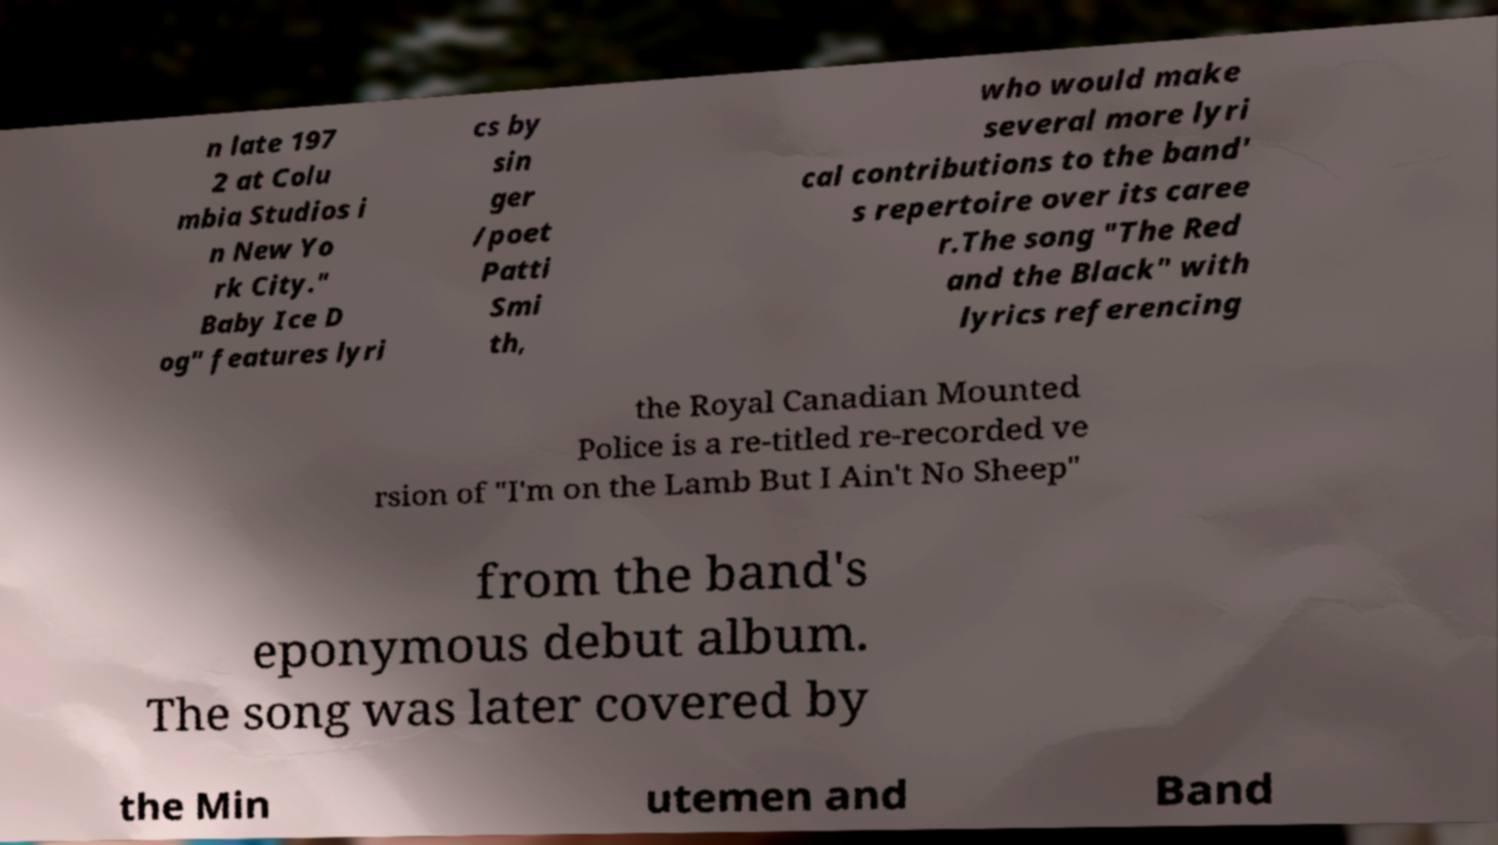Could you assist in decoding the text presented in this image and type it out clearly? n late 197 2 at Colu mbia Studios i n New Yo rk City." Baby Ice D og" features lyri cs by sin ger /poet Patti Smi th, who would make several more lyri cal contributions to the band' s repertoire over its caree r.The song "The Red and the Black" with lyrics referencing the Royal Canadian Mounted Police is a re-titled re-recorded ve rsion of "I'm on the Lamb But I Ain't No Sheep" from the band's eponymous debut album. The song was later covered by the Min utemen and Band 